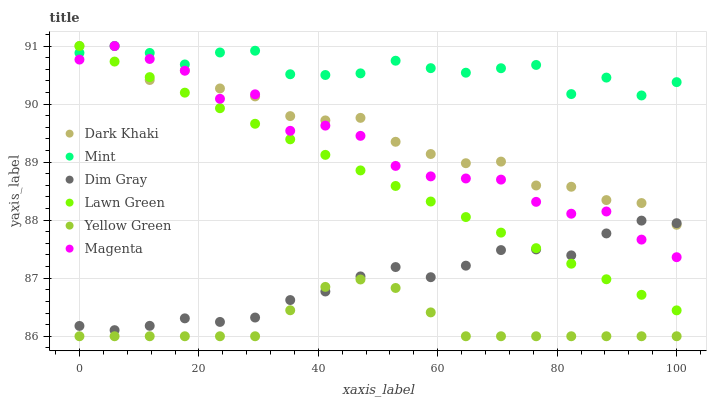Does Yellow Green have the minimum area under the curve?
Answer yes or no. Yes. Does Mint have the maximum area under the curve?
Answer yes or no. Yes. Does Dim Gray have the minimum area under the curve?
Answer yes or no. No. Does Dim Gray have the maximum area under the curve?
Answer yes or no. No. Is Lawn Green the smoothest?
Answer yes or no. Yes. Is Magenta the roughest?
Answer yes or no. Yes. Is Dim Gray the smoothest?
Answer yes or no. No. Is Dim Gray the roughest?
Answer yes or no. No. Does Yellow Green have the lowest value?
Answer yes or no. Yes. Does Dim Gray have the lowest value?
Answer yes or no. No. Does Mint have the highest value?
Answer yes or no. Yes. Does Dim Gray have the highest value?
Answer yes or no. No. Is Yellow Green less than Lawn Green?
Answer yes or no. Yes. Is Mint greater than Yellow Green?
Answer yes or no. Yes. Does Dim Gray intersect Yellow Green?
Answer yes or no. Yes. Is Dim Gray less than Yellow Green?
Answer yes or no. No. Is Dim Gray greater than Yellow Green?
Answer yes or no. No. Does Yellow Green intersect Lawn Green?
Answer yes or no. No. 